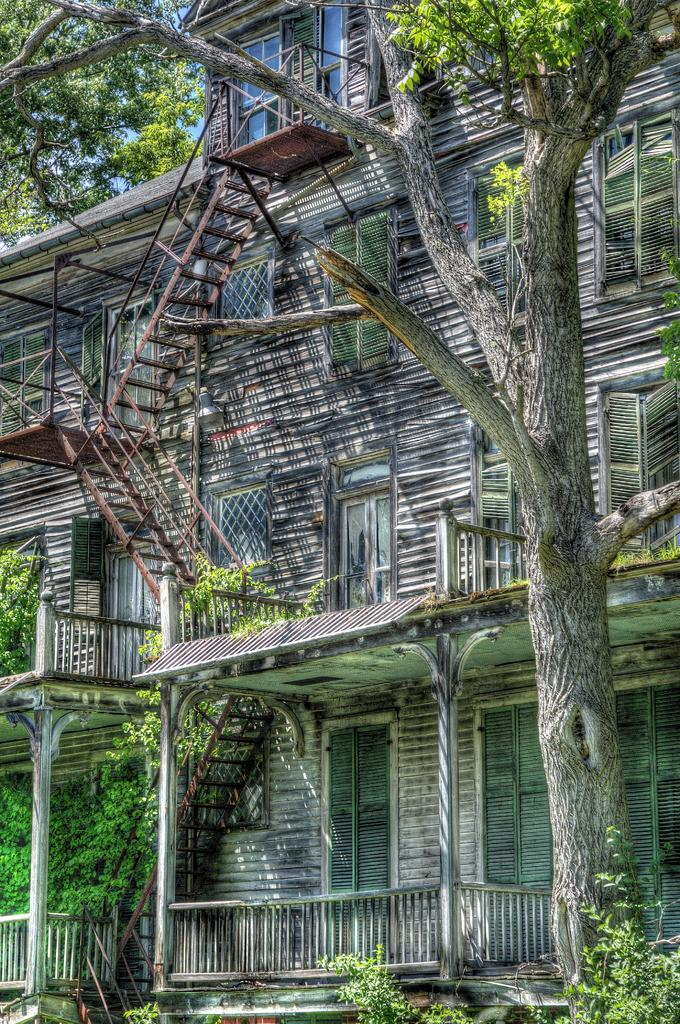What type of vegetation is on the right side of the image? There is a tree on the right side of the image. What can be seen in the background of the image? There is a building in the background of the image. What features does the building have? The building has a fence, windows, and stairs. What type of acoustics can be heard from the building in the image? There is no information about the acoustics of the building in the image, as it only provides visual details. What company owns the building in the image? There is no information about the company that owns the building in the image. 